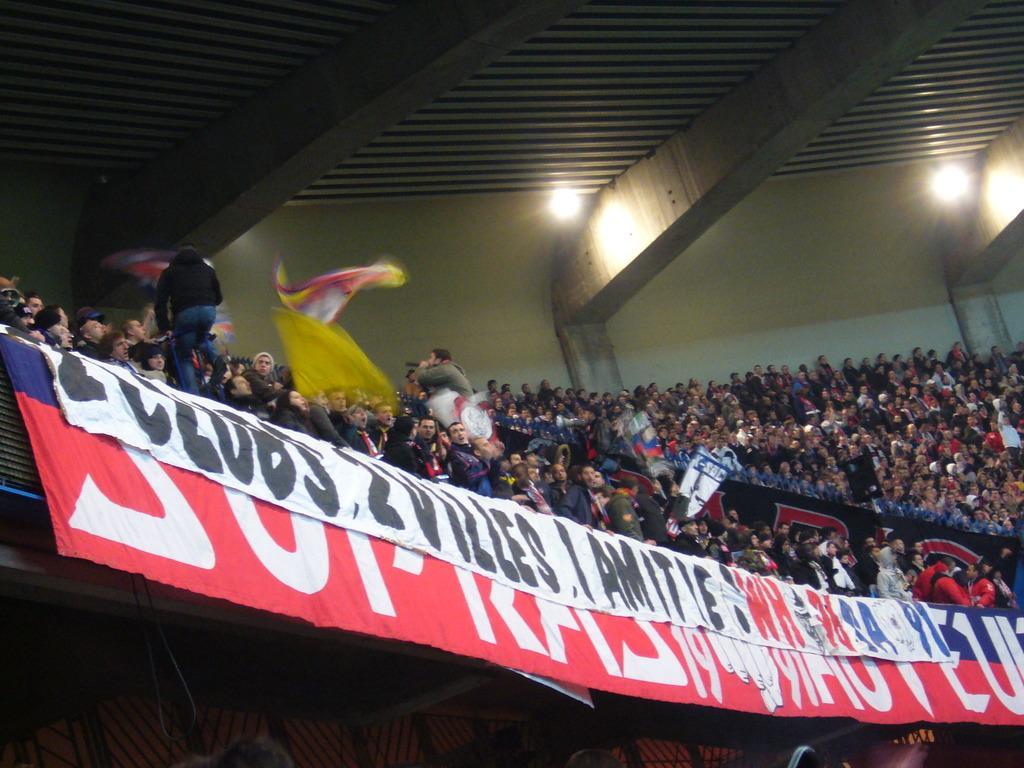Please provide a concise description of this image. The picture is taken in a stadium. In the foreground of the picture there are banners. In the center of the picture there are audience waving flags, few are standing and others sitting in chairs. At the top there are lights and ceiling. 